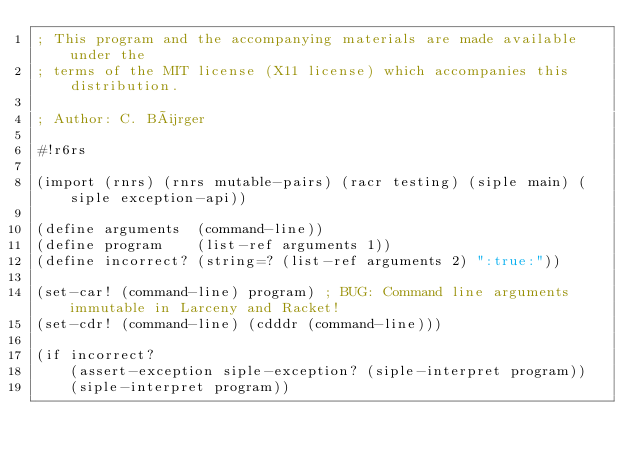<code> <loc_0><loc_0><loc_500><loc_500><_Scheme_>; This program and the accompanying materials are made available under the
; terms of the MIT license (X11 license) which accompanies this distribution.

; Author: C. Bürger

#!r6rs

(import (rnrs) (rnrs mutable-pairs) (racr testing) (siple main) (siple exception-api))

(define arguments  (command-line))
(define program    (list-ref arguments 1))
(define incorrect? (string=? (list-ref arguments 2) ":true:"))

(set-car! (command-line) program) ; BUG: Command line arguments immutable in Larceny and Racket!
(set-cdr! (command-line) (cdddr (command-line)))

(if incorrect?
    (assert-exception siple-exception? (siple-interpret program))
    (siple-interpret program))</code> 